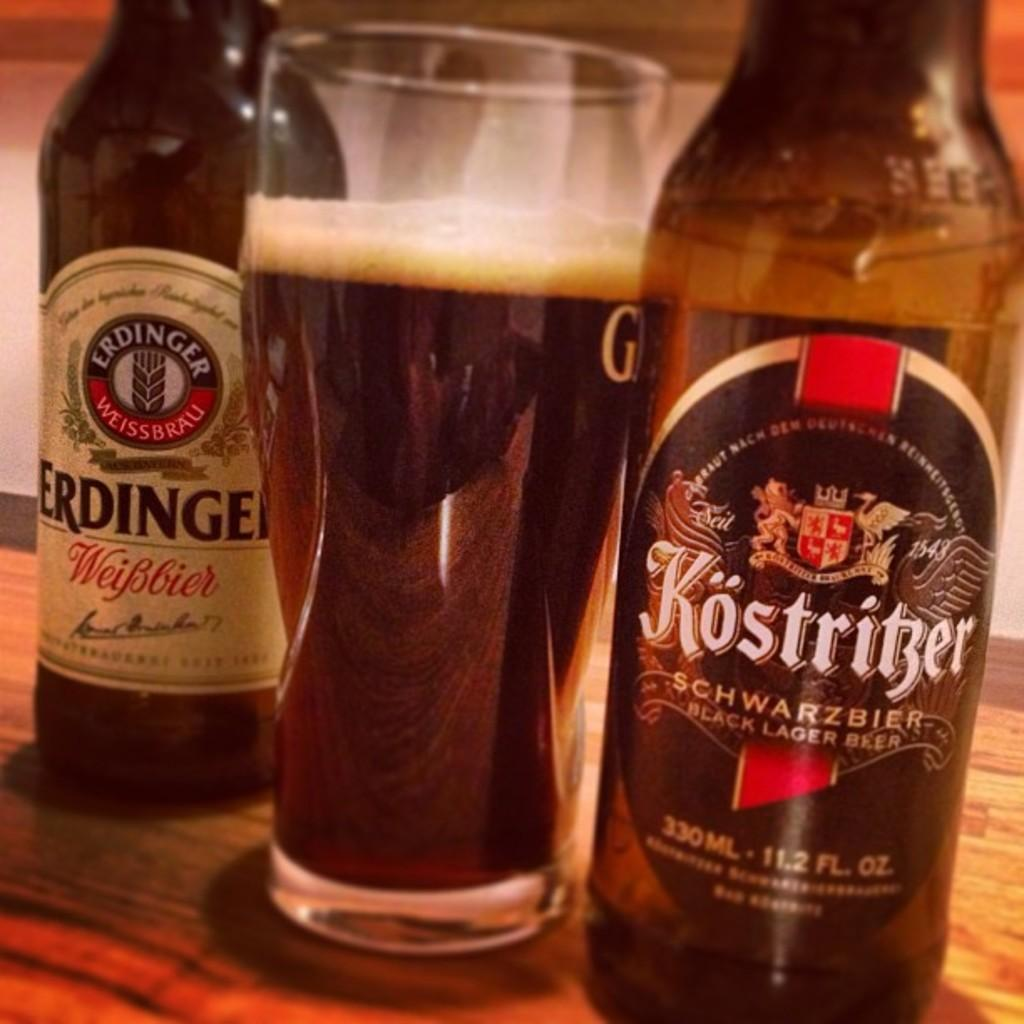<image>
Offer a succinct explanation of the picture presented. a bottle of kostritzer schwarzbier black lager beer 